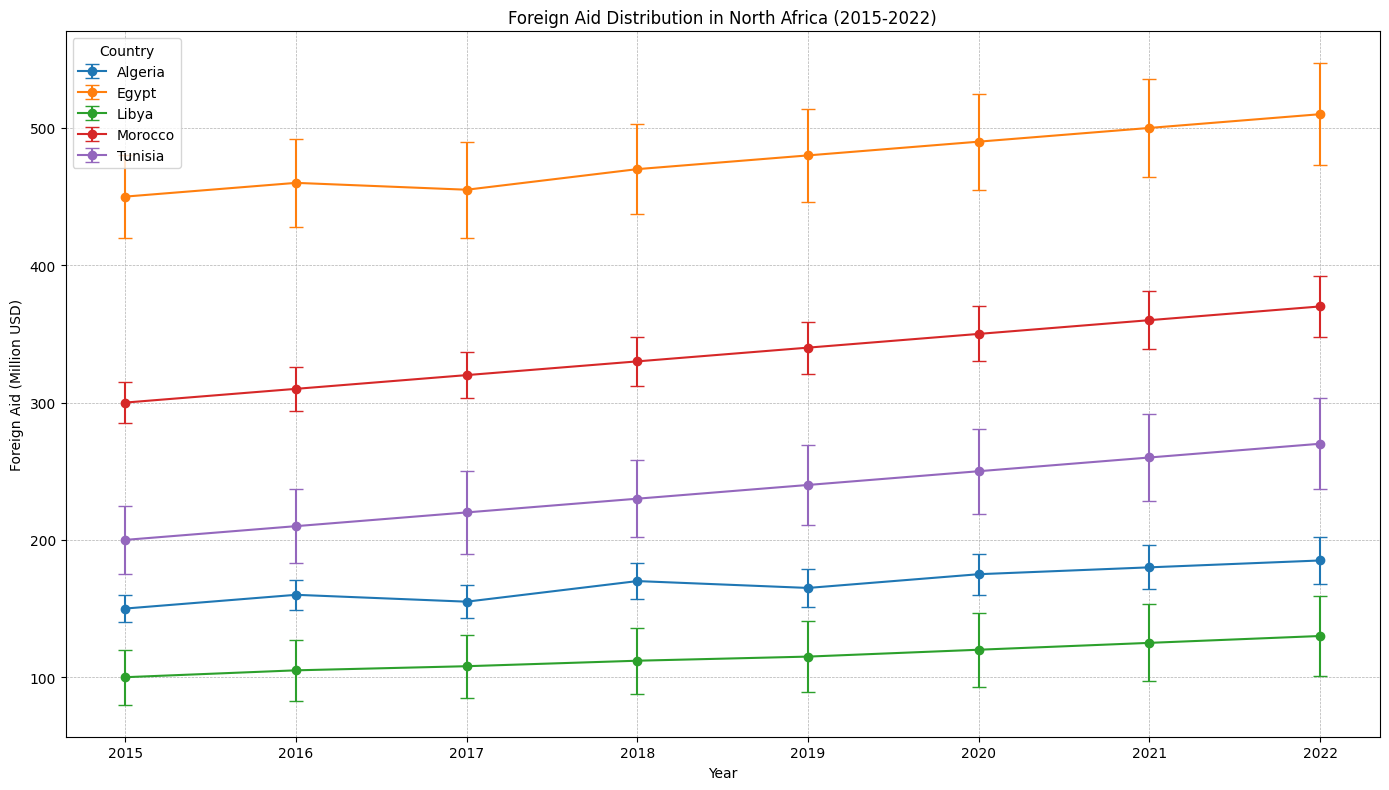What is the country with the highest foreign aid in 2022? From the plot, identify the country with the highest mark in the 2022 x-axis year. It is the single peak among all the data for 2022.
Answer: Egypt Which country has the largest uncertainty in its foreign aid in 2021? Look for the data point with the largest error bar (vertical line) for the year 2021. The longest error bar in 2021 corresponds to the largest uncertainty.
Answer: Tunisia Between 2018 and 2019, which country showed a decrease in foreign aid? Compare the data points for each country from 2018 to 2019 to see if the y-value (foreign aid) decreased. Identify the country with a downward trend.
Answer: Algeria What is the average foreign aid received by Libya from 2015 to 2022? Sum the foreign aid amounts for Libya from all years (2015-2022) and divide by the number of years (8) to find the average. Calculation: (100 + 105 + 108 + 112 + 115 + 120 + 125 + 130) / 8.
Answer: 114.375 Which country has consistently increasing foreign aid from 2015 to 2022 without any decrease in any year? Identify the country whose data points form a strictly increasing trend line from 2015 to 2022 without any year showing a decrease in foreign aid.
Answer: Egypt What is the difference in foreign aid received by Morocco between 2016 and 2020? Note the foreign aid values for Morocco in 2016 and 2020, then subtract the 2016 value from the 2020 value to find the difference. Calculation: 350 - 310 = 40.
Answer: 40 Which year did Tunisia receive the highest amount of foreign aid, and what was the amount? Locate the peak data point for Tunisia across all years, then note down the year and the corresponding foreign aid value.
Answer: 2022, 270 Million USD Comparing Libya and Tunisia in 2022, which country had a larger uncertainty in their foreign aid, and by how much? Compare the lengths of the error bars for Libya and Tunisia in 2022, then subtract the smaller length from the larger one to find the difference. Calculation: 33 - 29 = 4.
Answer: Tunisia, 4 Million USD What is the range of foreign aid received by Algeria from 2015 to 2022? Identify the maximum and minimum foreign aid values for Algeria between 2015 and 2022, then subtract the minimum from the maximum to find the range. Calculation: 185 - 150 = 35.
Answer: 35 Million USD 